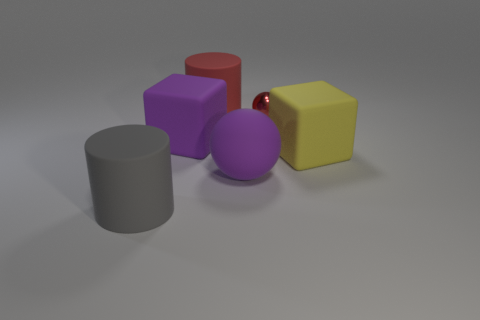Subtract 1 cylinders. How many cylinders are left? 1 Add 1 big spheres. How many objects exist? 7 Subtract all balls. How many objects are left? 4 Subtract all blue cylinders. Subtract all big cylinders. How many objects are left? 4 Add 1 purple balls. How many purple balls are left? 2 Add 1 matte objects. How many matte objects exist? 6 Subtract 0 green cylinders. How many objects are left? 6 